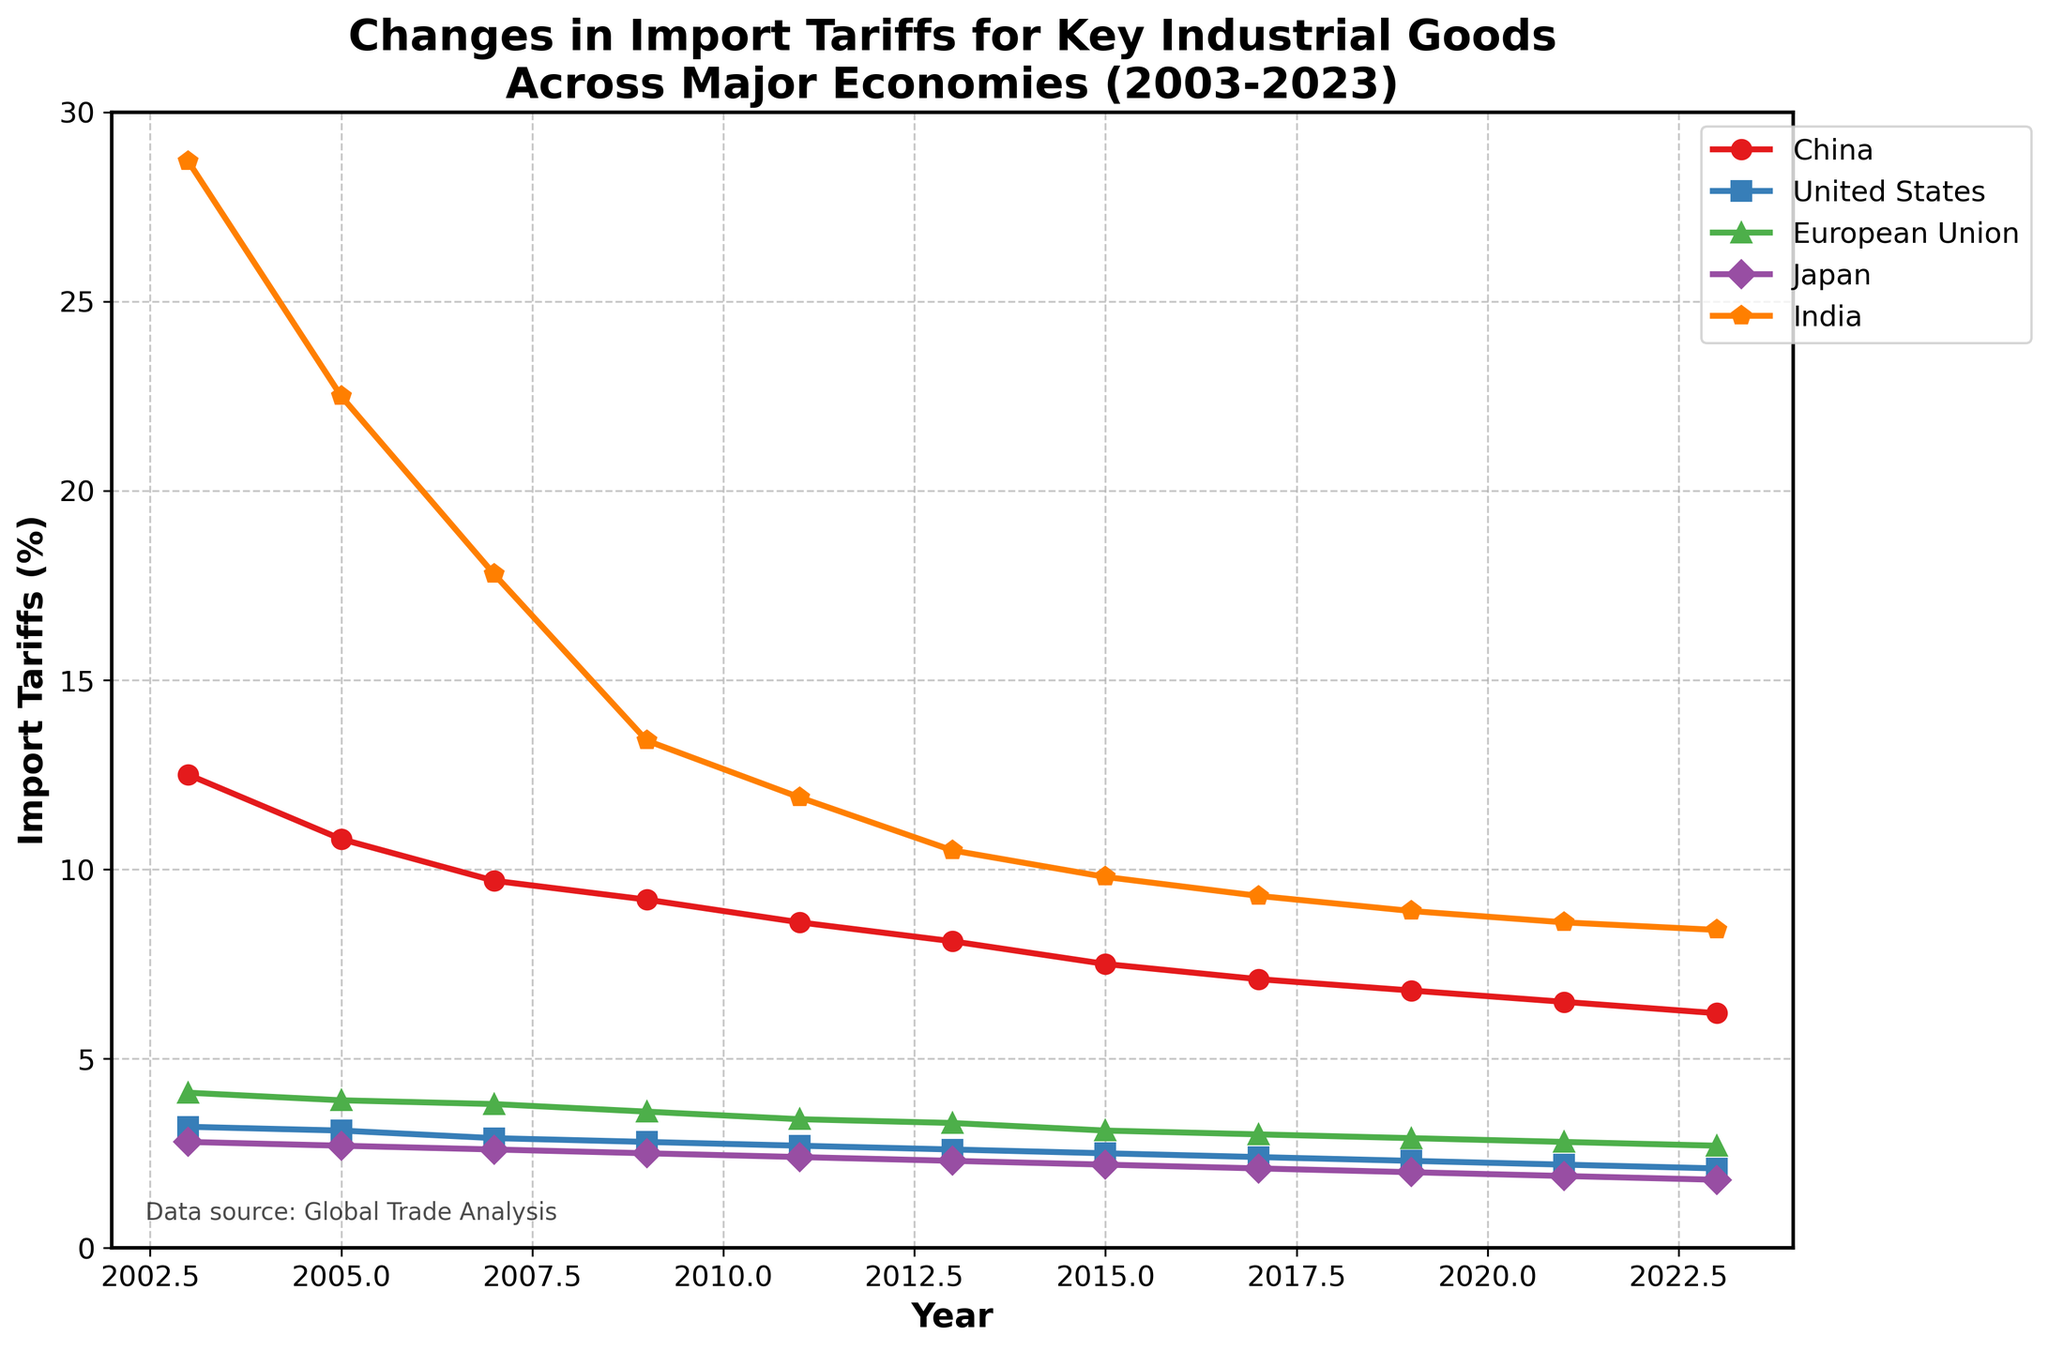What is the trend in China's import tariffs from 2003 to 2023? The figure shows a line graph for China with import tariffs starting at 12.5% in 2003 and gradually decreasing to 6.2% in 2023.
Answer: Decreasing Which country had the highest import tariffs in 2023? By comparing the endpoints of all the countries' lines in the year 2023, India's line is at the highest position with 8.4%.
Answer: India How did the average import tariffs of China, the United States, and the European Union change from 2003 to 2023? We calculate the average for each year and compare the starting and ending values: 
2003: (12.5 + 3.2 + 4.1)/3 = 6.6 
2023: (6.2 + 2.1 + 2.7)/3 = 3.67. 
This shows a decrease from 6.6% to 3.67%.
Answer: Decreased Between which two consecutive years did Japan see its largest drop in import tariffs? By analyzing the slope of the Japan line between consecutive points, the largest vertical drop is between 2003 (2.8) to 2005 (2.7) and between 2019 (2.0) to 2021 (1.9), each having a drop of 0.1.
Answer: 2003-2005 and 2019-2021 From 2003 to 2023, how much did India's import tariffs decrease on an absolute scale? The decrease is calculated by subtracting the import tariff in 2023 from that in 2003: 28.7 - 8.4 = 20.3.
Answer: 20.3 In which year did China’s import tariffs fall below 10% for the first time? The line chart for China falls below 10% between 2005 (10.8) and 2007 (9.7), so 2007 is the first year where it is below 10%.
Answer: 2007 What is the approximate average import tariff for Japan over the entire period? Sum the import tariffs for Japan from 2003 to 2023 and divide by the number of years: 
(2.8 + 2.7 + 2.6 + 2.5 + 2.4 + 2.3 + 2.2 + 2.1 + 2.0 + 1.9 + 1.8) / 11 ≈ 2.3.
Answer: 2.3 Compare the steepest declines in import tariffs over a decade for China and the United States. Which country had the sharper decrease? For China, from 2003 to 2013, the tariff drop is 12.5 - 8.1 = 4.4. For the United States, from 2003 to 2013, the drop is 3.2 - 2.6 = 0.6. China has the sharper decade decline.
Answer: China Which country shows the least variability in import tariffs over the 20 years? Observing the lines' fluctuation, the United States line shows the least movement, indicating the least variability.
Answer: United States 